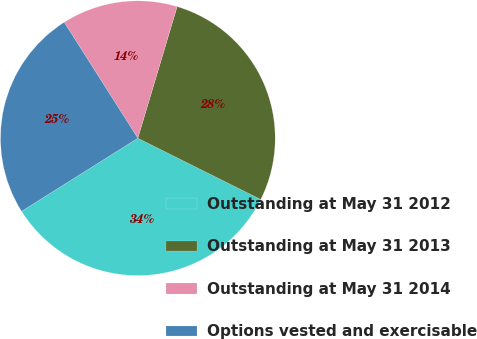<chart> <loc_0><loc_0><loc_500><loc_500><pie_chart><fcel>Outstanding at May 31 2012<fcel>Outstanding at May 31 2013<fcel>Outstanding at May 31 2014<fcel>Options vested and exercisable<nl><fcel>33.71%<fcel>27.74%<fcel>13.63%<fcel>24.93%<nl></chart> 